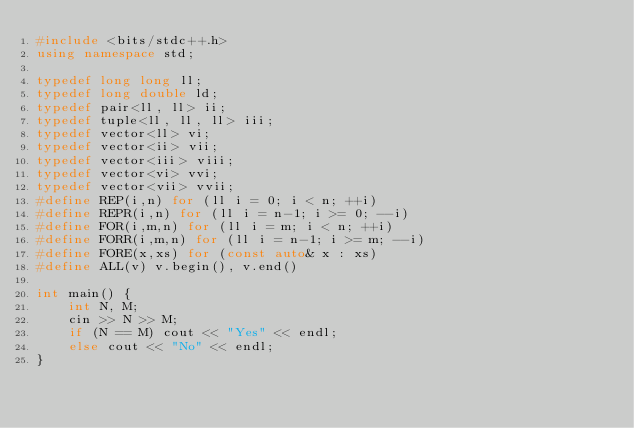Convert code to text. <code><loc_0><loc_0><loc_500><loc_500><_C++_>#include <bits/stdc++.h>
using namespace std;

typedef long long ll;
typedef long double ld;
typedef pair<ll, ll> ii;
typedef tuple<ll, ll, ll> iii;
typedef vector<ll> vi;
typedef vector<ii> vii;
typedef vector<iii> viii;
typedef vector<vi> vvi;
typedef vector<vii> vvii;
#define REP(i,n) for (ll i = 0; i < n; ++i)
#define REPR(i,n) for (ll i = n-1; i >= 0; --i)
#define FOR(i,m,n) for (ll i = m; i < n; ++i)
#define FORR(i,m,n) for (ll i = n-1; i >= m; --i)
#define FORE(x,xs) for (const auto& x : xs)
#define ALL(v) v.begin(), v.end()

int main() {
    int N, M;
    cin >> N >> M;
    if (N == M) cout << "Yes" << endl;
    else cout << "No" << endl;
}</code> 